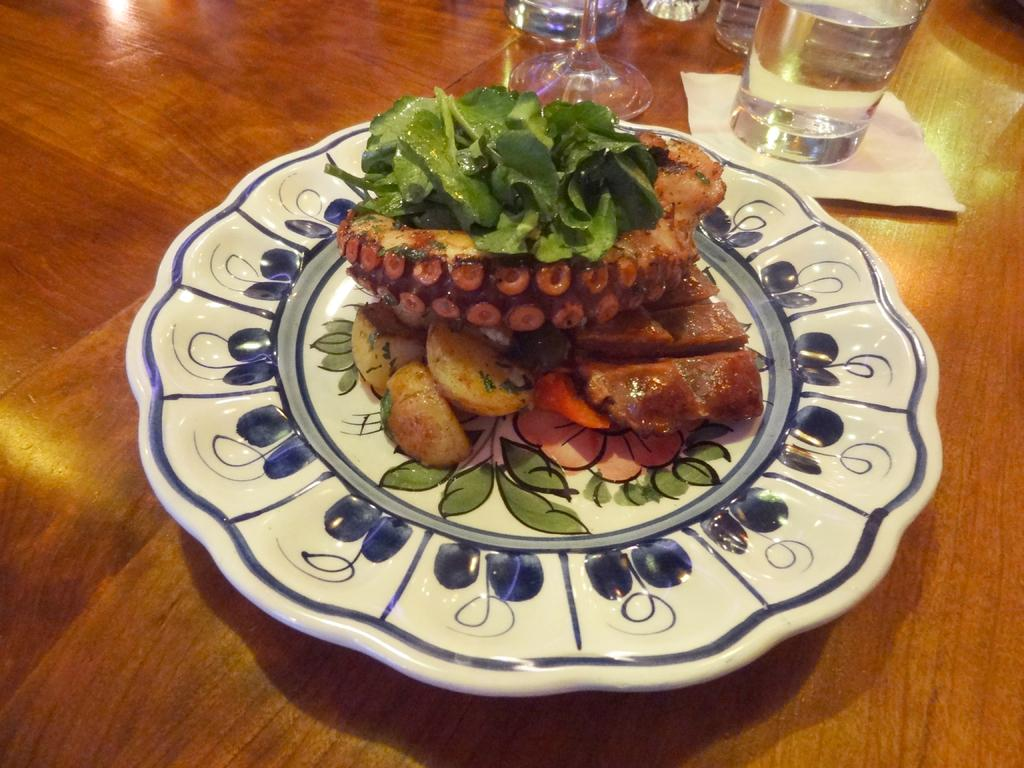What type of table is in the image? There is a wooden table in the image. What is on the table? There is a glass of water, tissue paper, and a plate containing food items on the table. What can be used to clean or wipe in the image? Tissue paper is present on the table for cleaning or wiping. What is the plate used for in the image? The plate is used to hold food items in the image. How many women are holding sticks in the image? There are no women or sticks present in the image. 